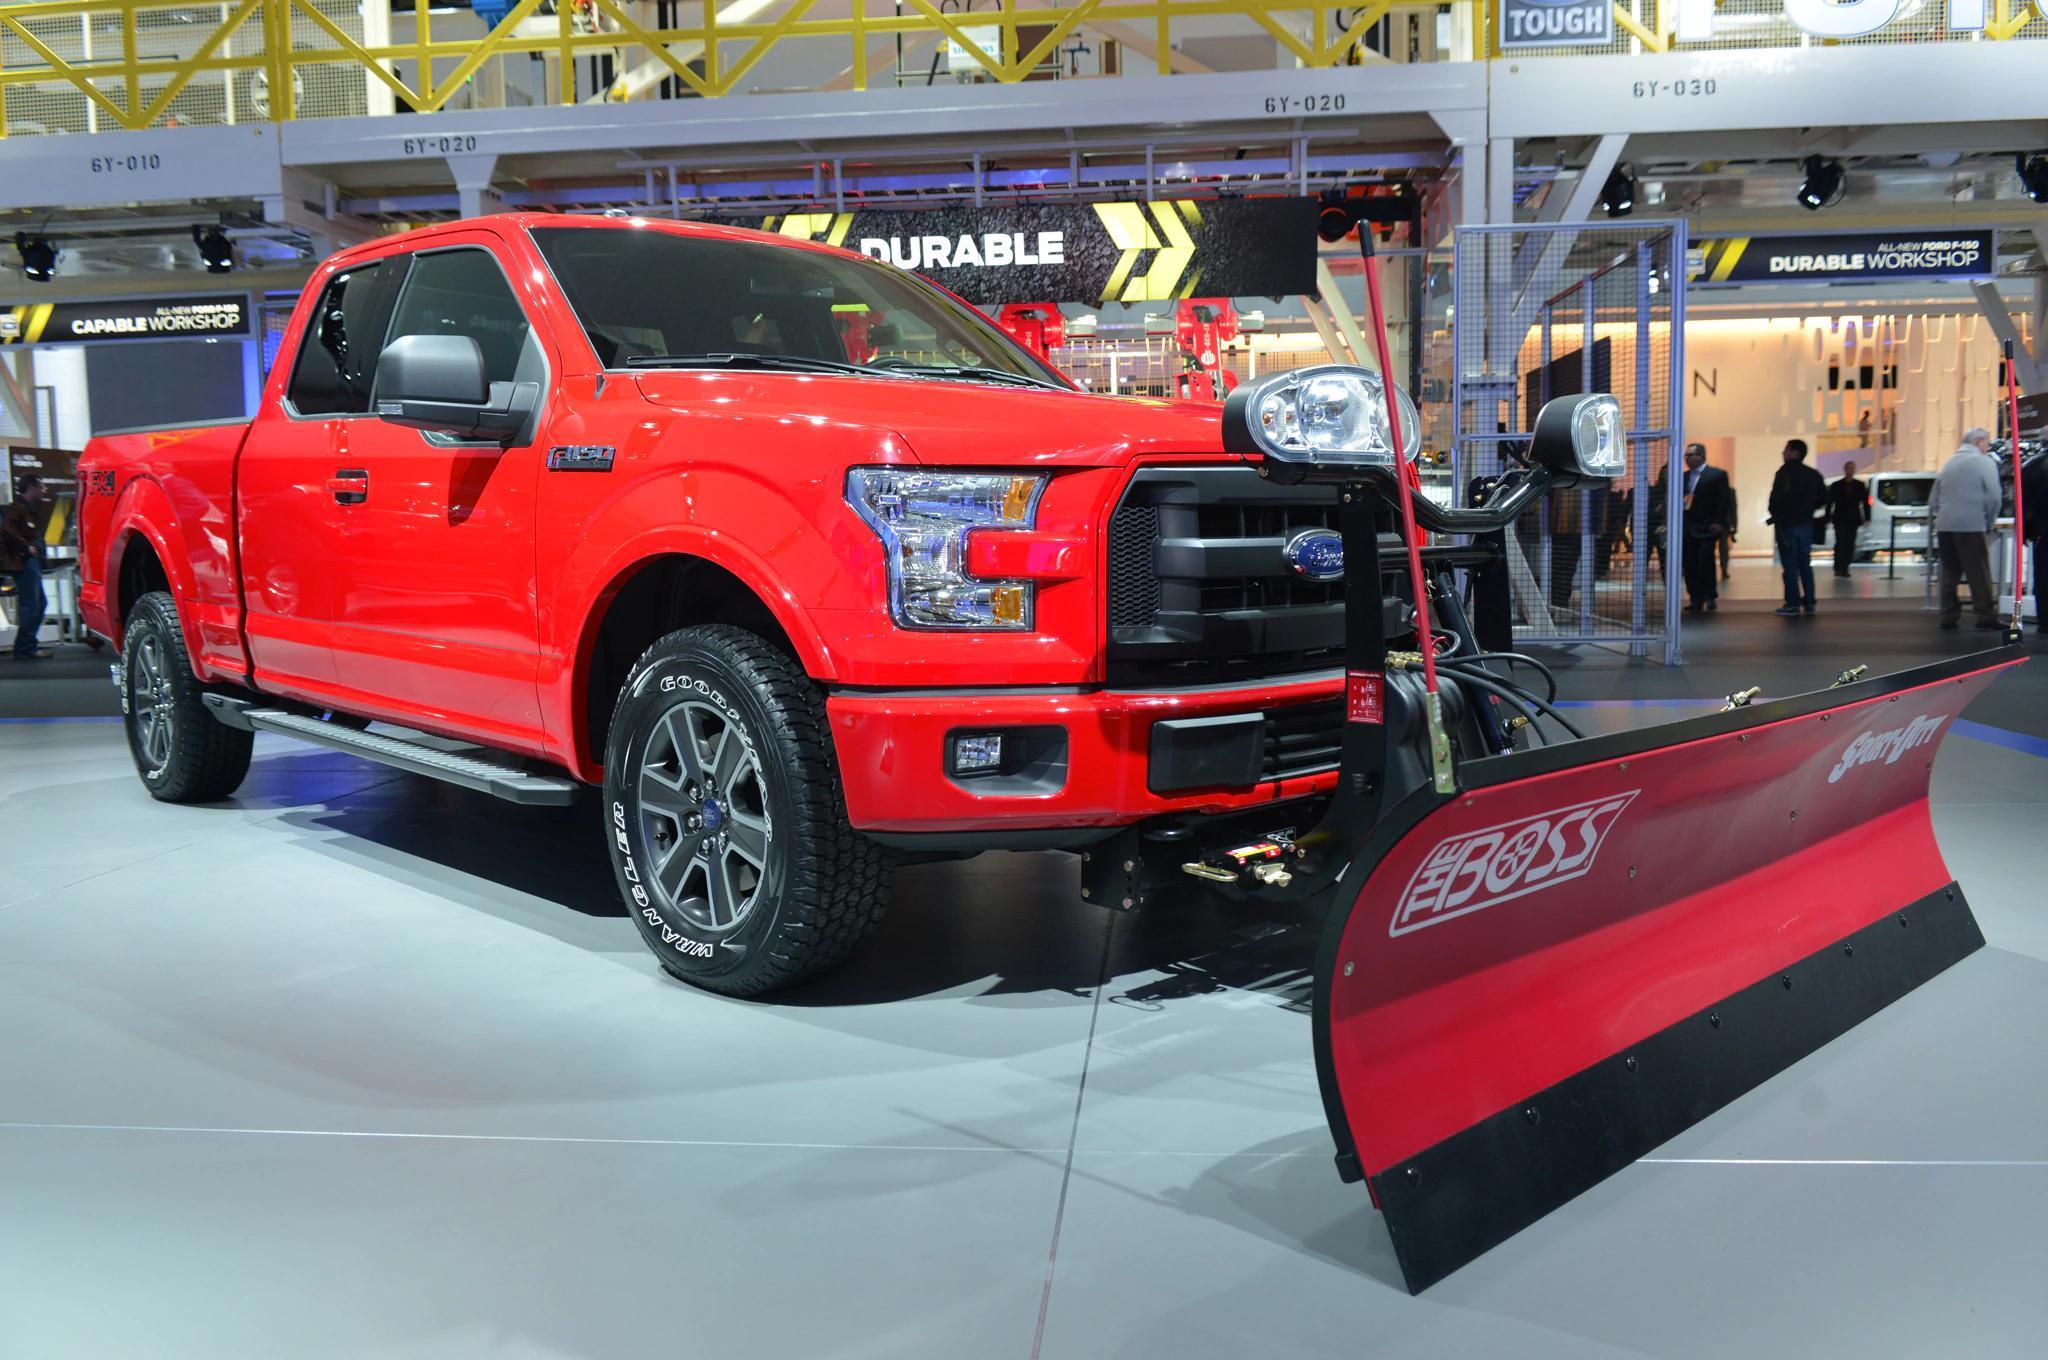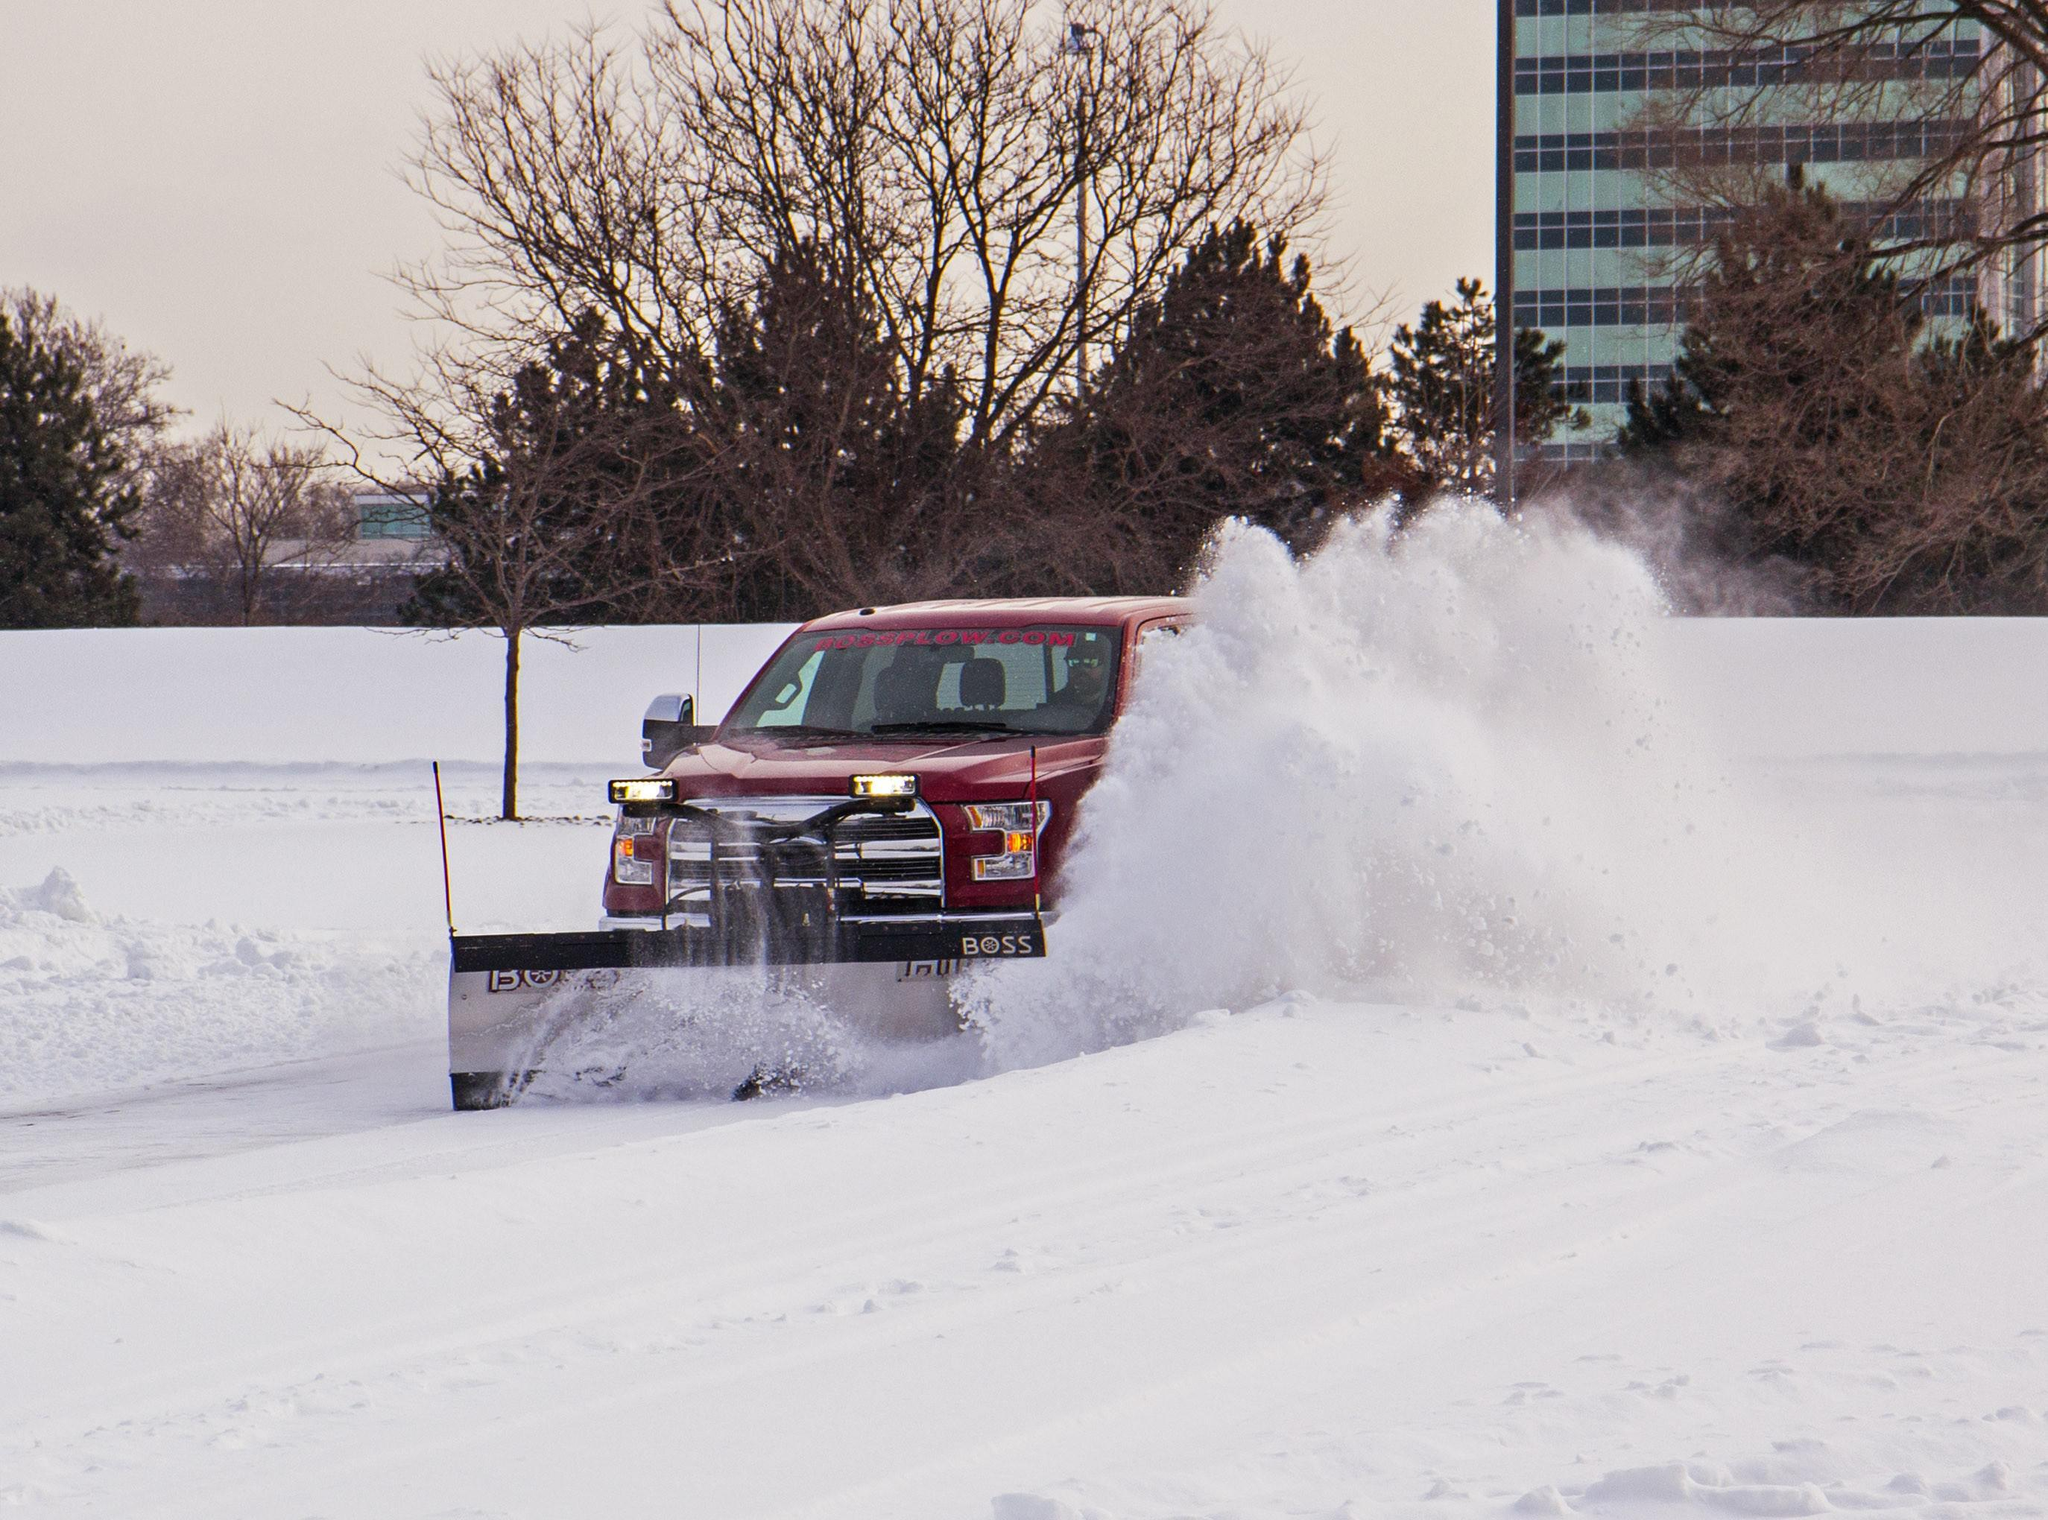The first image is the image on the left, the second image is the image on the right. Assess this claim about the two images: "One image shows a non-red pickup truck pushing a large mound of snow with a plow.". Correct or not? Answer yes or no. No. 